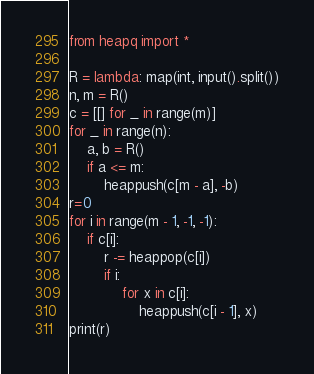<code> <loc_0><loc_0><loc_500><loc_500><_Python_>from heapq import *

R = lambda: map(int, input().split())
n, m = R()
c = [[] for _ in range(m)]
for _ in range(n):
    a, b = R()
    if a <= m:
        heappush(c[m - a], -b)
r=0
for i in range(m - 1, -1, -1):
    if c[i]:
        r -= heappop(c[i])
        if i:
            for x in c[i]:
                heappush(c[i - 1], x)  
print(r)
</code> 